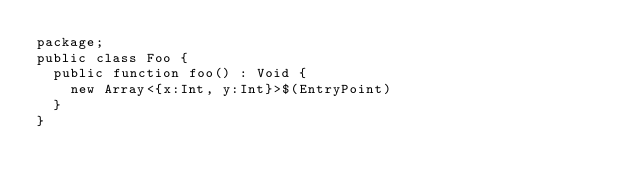Convert code to text. <code><loc_0><loc_0><loc_500><loc_500><_Haxe_>package;
public class Foo {
	public function foo() : Void {
		new Array<{x:Int, y:Int}>$(EntryPoint)
	}
}</code> 